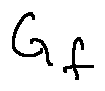<formula> <loc_0><loc_0><loc_500><loc_500>G _ { f }</formula> 